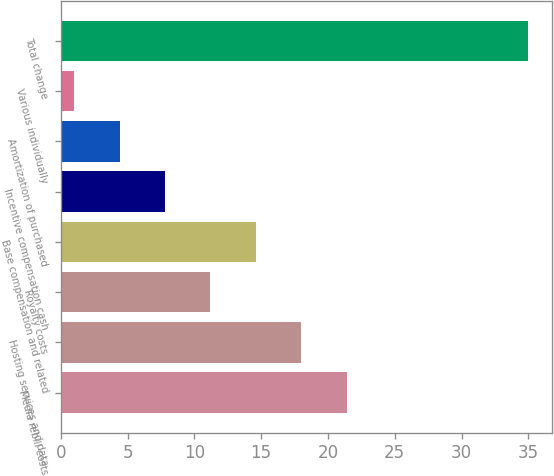<chart> <loc_0><loc_0><loc_500><loc_500><bar_chart><fcel>Media rebill costs<fcel>Hosting services and data<fcel>Royalty costs<fcel>Base compensation and related<fcel>Incentive compensation cash<fcel>Amortization of purchased<fcel>Various individually<fcel>Total change<nl><fcel>21.4<fcel>18<fcel>11.2<fcel>14.6<fcel>7.8<fcel>4.4<fcel>1<fcel>35<nl></chart> 